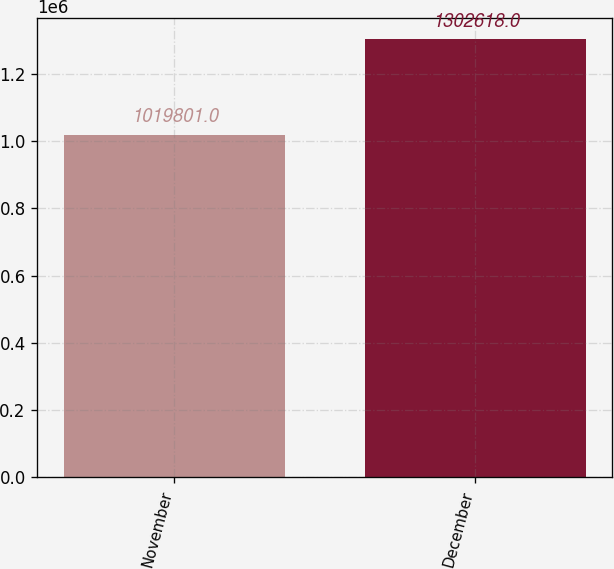Convert chart. <chart><loc_0><loc_0><loc_500><loc_500><bar_chart><fcel>November<fcel>December<nl><fcel>1.0198e+06<fcel>1.30262e+06<nl></chart> 